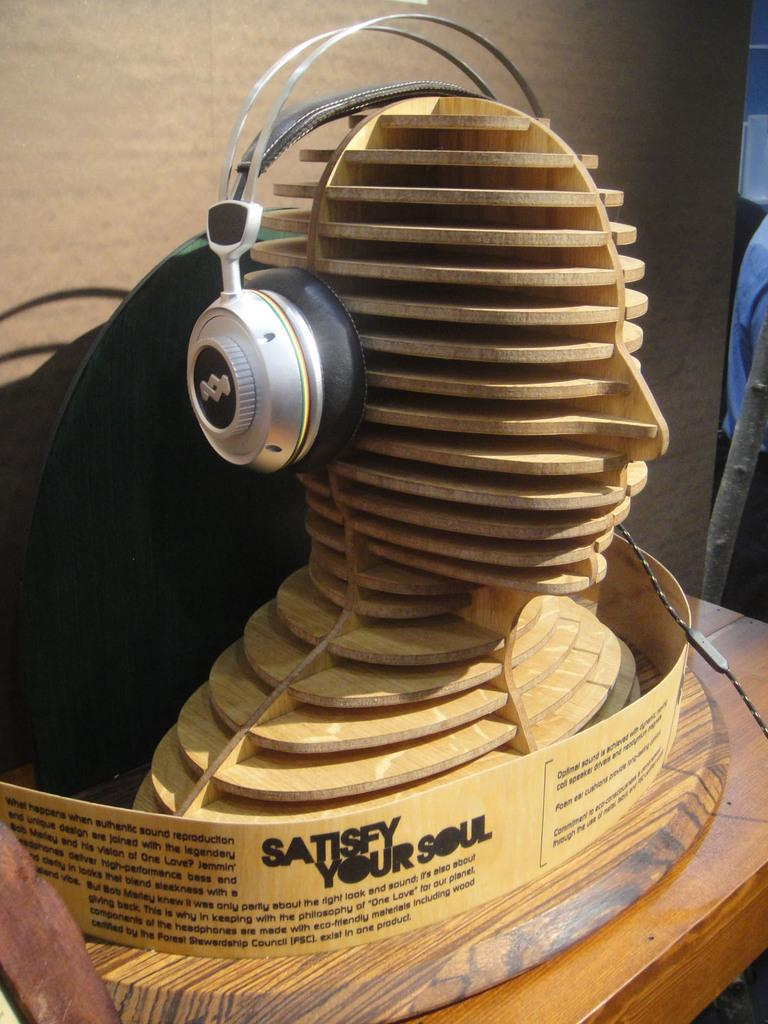What is the main subject in the center of the image? There is a sculpture in the center of the image. What electronic device can be seen on the table? There is a headset placed on the table. What can be seen in the background of the image? There is a wall in the background of the image. How does the earthquake affect the sculpture in the image? There is no earthquake present in the image, so its effect on the sculpture cannot be determined. 